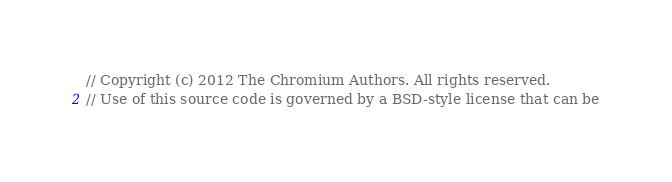Convert code to text. <code><loc_0><loc_0><loc_500><loc_500><_ObjectiveC_>// Copyright (c) 2012 The Chromium Authors. All rights reserved.
// Use of this source code is governed by a BSD-style license that can be</code> 